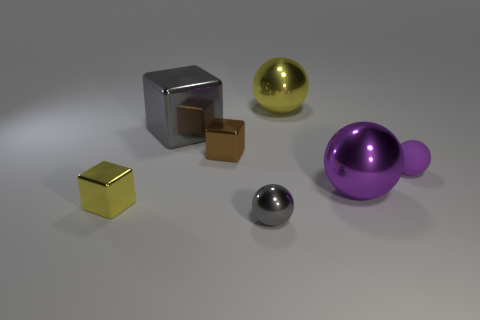Why do you think the artist chose these particular colors for the objects? The artist may have chosen these diverse colors to create a visually engaging composition that showcases contrasts and harmony between different hues, facilitating an exploration of color theory and the interaction of light with various surfaces. How might these colors affect the viewer's perception of the objects? The variety of colors can lead viewers to perceive each object as having its own distinct identity and material properties. Warmer colors, such as the gold of the cube, can seem more inviting, while cooler colors, such as the purple ball, might appear more distant or futuristic. 